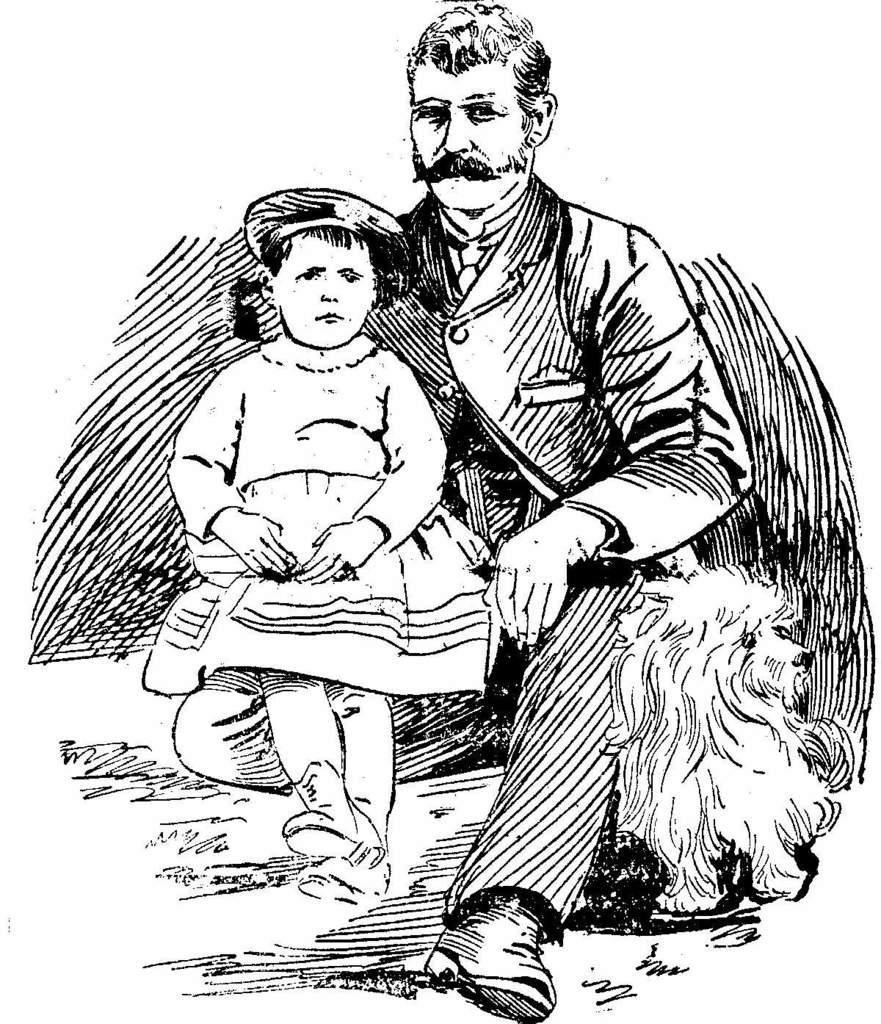In one or two sentences, can you explain what this image depicts? In this image I can see depiction of a man and of a girl. I can see this image is black and white in colour. Here I can see depiction of an animal. 